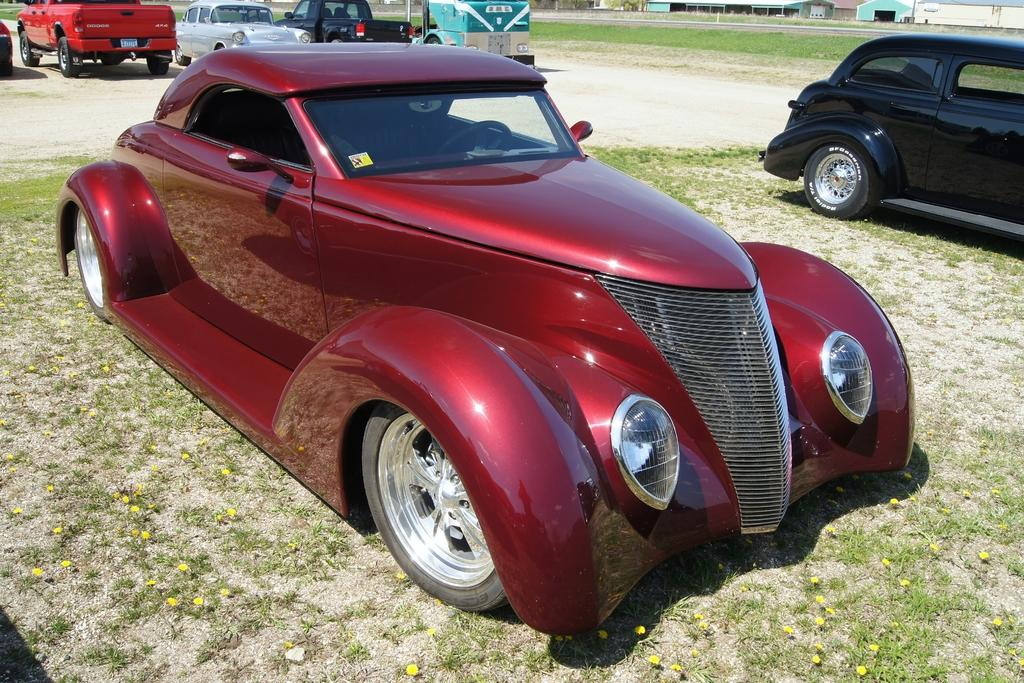What type of vehicles are parked on the land in the image? There are cars parked on the land in the image. Can you describe the background of the image? In the background of the image, there are big compartments. How many babies are playing with sleet in the image? There are no babies or sleet present in the image. What type of seed can be seen growing near the cars in the image? There is no seed growing near the cars in the image. 